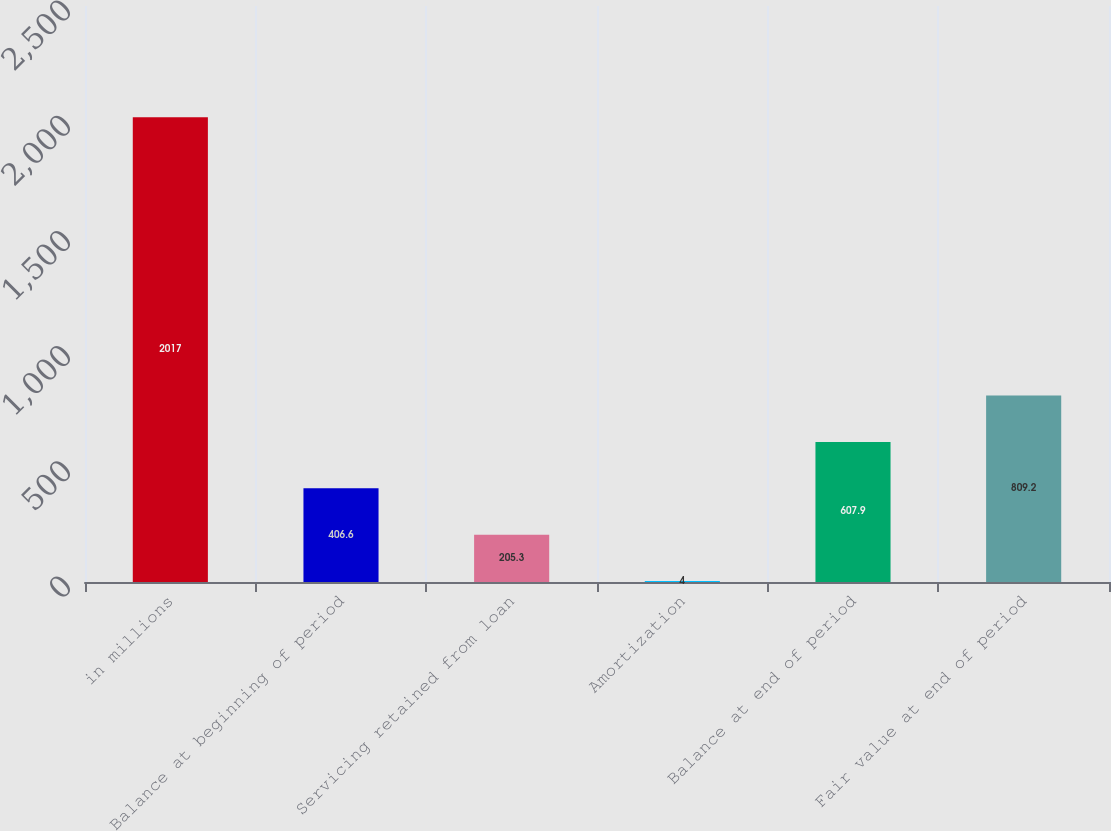Convert chart to OTSL. <chart><loc_0><loc_0><loc_500><loc_500><bar_chart><fcel>in millions<fcel>Balance at beginning of period<fcel>Servicing retained from loan<fcel>Amortization<fcel>Balance at end of period<fcel>Fair value at end of period<nl><fcel>2017<fcel>406.6<fcel>205.3<fcel>4<fcel>607.9<fcel>809.2<nl></chart> 